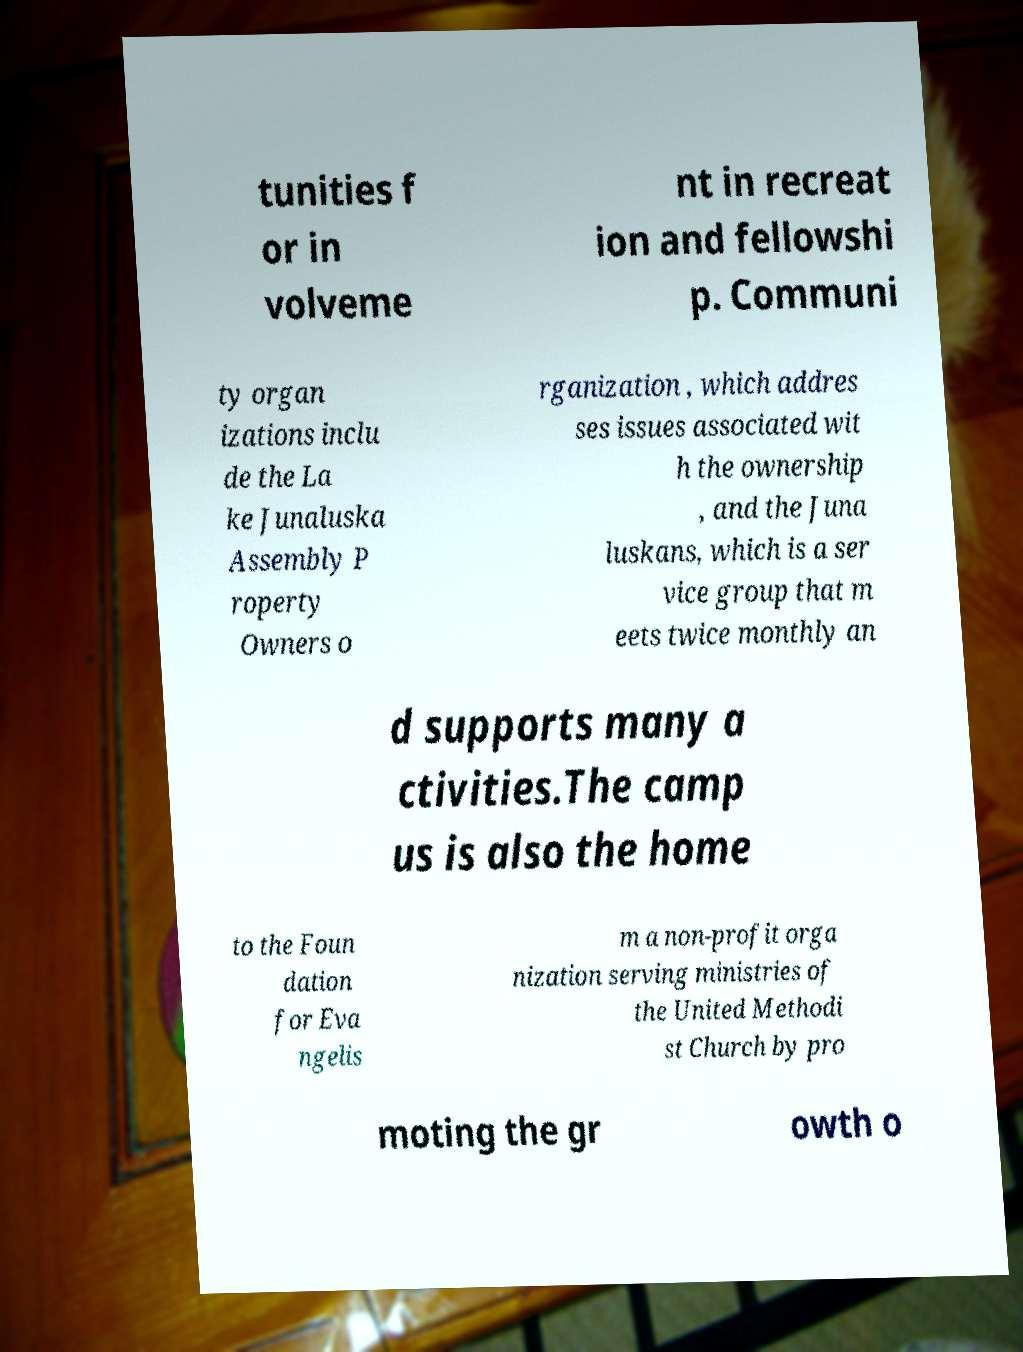What messages or text are displayed in this image? I need them in a readable, typed format. tunities f or in volveme nt in recreat ion and fellowshi p. Communi ty organ izations inclu de the La ke Junaluska Assembly P roperty Owners o rganization , which addres ses issues associated wit h the ownership , and the Juna luskans, which is a ser vice group that m eets twice monthly an d supports many a ctivities.The camp us is also the home to the Foun dation for Eva ngelis m a non-profit orga nization serving ministries of the United Methodi st Church by pro moting the gr owth o 